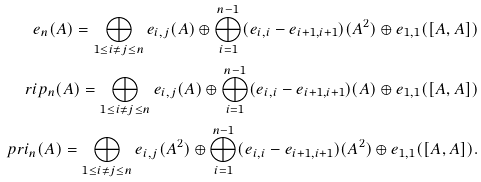<formula> <loc_0><loc_0><loc_500><loc_500>\ e _ { n } ( A ) = \bigoplus _ { 1 \leq i \ne j \leq n } e _ { i , j } ( A ) \oplus \bigoplus _ { i = 1 } ^ { n - 1 } ( e _ { i , i } - e _ { { i + 1 } , { i + 1 } } ) ( A ^ { 2 } ) \oplus e _ { 1 , 1 } ( [ A , A ] ) \\ \ r i p _ { n } ( A ) = \bigoplus _ { 1 \leq i \ne j \leq n } e _ { i , j } ( A ) \oplus \bigoplus _ { i = 1 } ^ { n - 1 } ( e _ { i , i } - e _ { { i + 1 } , { i + 1 } } ) ( A ) \oplus e _ { 1 , 1 } ( [ A , A ] ) \\ \ p r i _ { n } ( A ) = \bigoplus _ { 1 \leq i \ne j \leq n } e _ { i , j } ( A ^ { 2 } ) \oplus \bigoplus _ { i = 1 } ^ { n - 1 } ( e _ { i , i } - e _ { i + 1 , i + 1 } ) ( A ^ { 2 } ) \oplus e _ { 1 , 1 } ( [ A , A ] ) . \\</formula> 